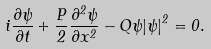<formula> <loc_0><loc_0><loc_500><loc_500>i \frac { \partial \psi } { \partial t } + \frac { P } { 2 } \frac { \partial ^ { 2 } \psi } { \partial x ^ { 2 } } - Q \psi { \left | \psi \right | } ^ { 2 } = 0 .</formula> 